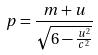<formula> <loc_0><loc_0><loc_500><loc_500>p = \frac { m + u } { \sqrt { 6 - \frac { u ^ { 2 } } { c ^ { 2 } } } }</formula> 